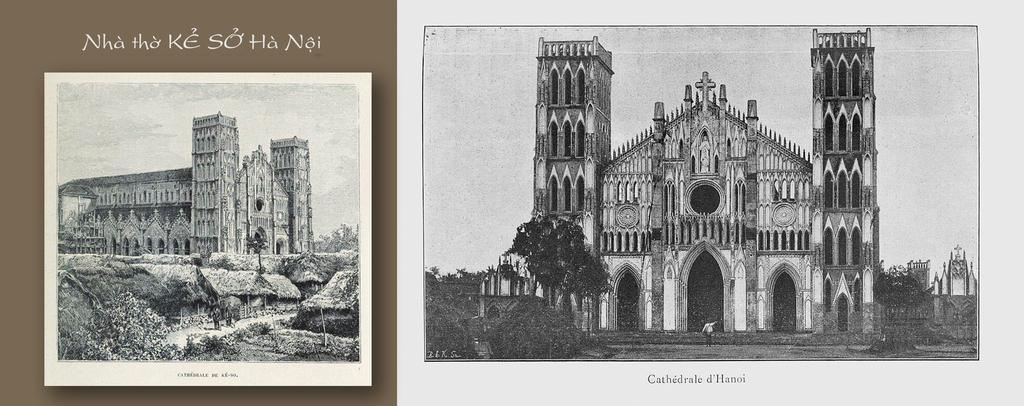What is the main subject of the paper in the image? The paper contains an image of a building. What else can be seen on the paper besides the image? There is text visible on the paper. What type of natural elements are present in the image? There are trees in the image. Can you tell me how many times the grandfather kicks the ball in the image? There is no grandfather or ball present in the image; it features a paper with an image of a building and text. 